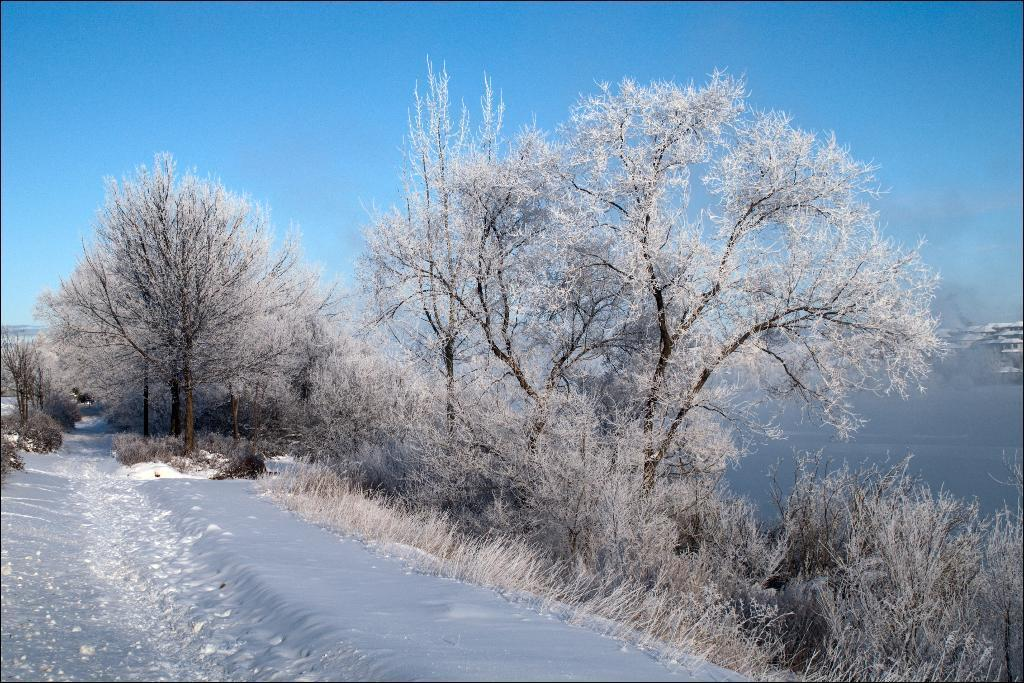What type of weather is depicted in the image? There is snow in the image, which suggests cold or wintry weather. What type of vegetation is visible in the image? There are trees in the image. What is visible in the background of the image? The sky is visible in the background of the image. Can you see any smoke coming from the trees in the image? There is no smoke visible in the image; it only features snow, trees, and the sky. Are there any caps visible on the trees in the image? There are no caps present on the trees in the image. 